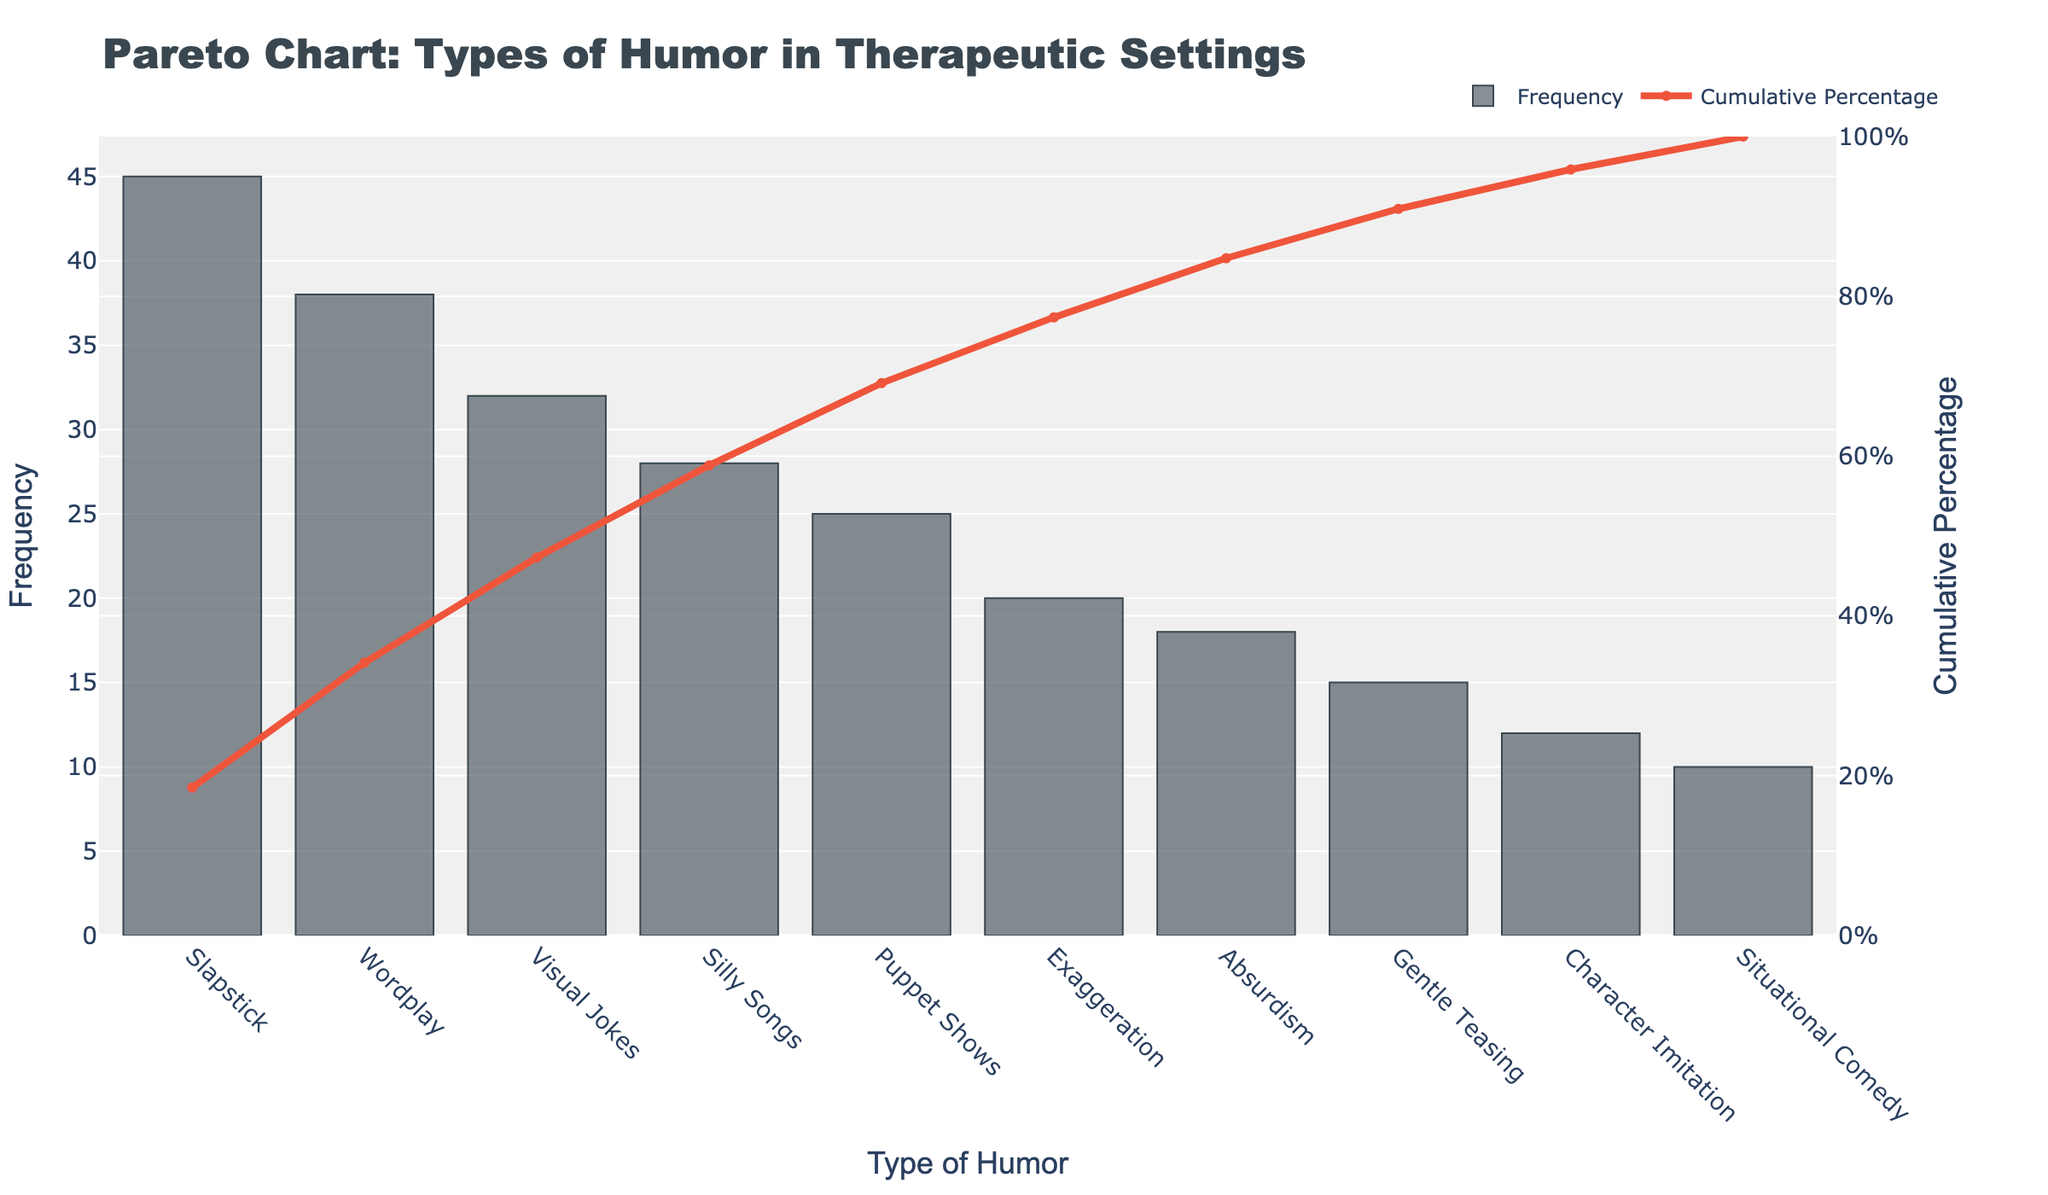What is the most common type of humor used in therapeutic settings for children with developmental disorders? The most common type of humor is the one with the highest bar in the chart.
Answer: Slapstick What is the cumulative percentage when including "Visual Jokes"? Look for the "Visual Jokes" bar and check the corresponding cumulative percentage line.
Answer: Around 68% How many types of humor have a frequency higher than 30? Identify the bars with a frequency above 30 and count them.
Answer: 3 Which type of humor has the least frequency? Look for the bar with the smallest height in the chart.
Answer: Situational Comedy What is the cumulative frequency percentage of the three most common types of humor? Sum the cumulative percentages of the top three types of humor (Slapstick, Wordplay, and Visual Jokes).
Answer: Around 70% What is the difference in frequency between "Slapstick" and "Character Imitation"? Subtract the frequency of Character Imitation from the frequency of Slapstick.
Answer: 33 What is the combined frequency of "Silly Songs" and "Puppet Shows"? Add the frequencies of Silly Songs and Puppet Shows.
Answer: 53 Which humor type contributes to reaching above 50% in cumulative frequency when sorted in descending order? Find the first type of humor where the cumulative percentage exceeds 50%.
Answer: Visual Jokes By how much does the frequency of "Gentle Teasing" differ from "Absurdism"? Subtract the frequency of Gentle Teasing from Absurdism.
Answer: 3 How many types of humor are needed to reach at least a 75% cumulative percentage? Add cumulative percentages until the total reaches or exceeds 75%.
Answer: 4 